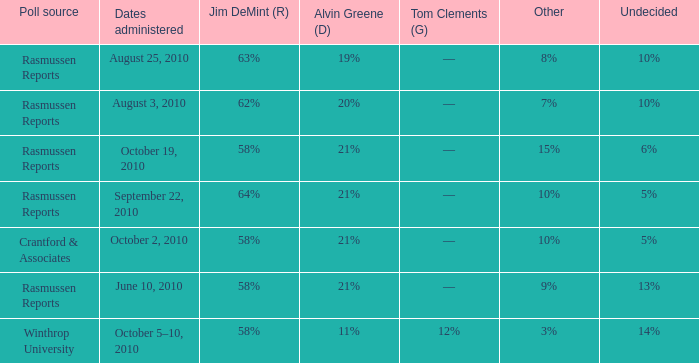I'm looking to parse the entire table for insights. Could you assist me with that? {'header': ['Poll source', 'Dates administered', 'Jim DeMint (R)', 'Alvin Greene (D)', 'Tom Clements (G)', 'Other', 'Undecided'], 'rows': [['Rasmussen Reports', 'August 25, 2010', '63%', '19%', '––', '8%', '10%'], ['Rasmussen Reports', 'August 3, 2010', '62%', '20%', '––', '7%', '10%'], ['Rasmussen Reports', 'October 19, 2010', '58%', '21%', '––', '15%', '6%'], ['Rasmussen Reports', 'September 22, 2010', '64%', '21%', '––', '10%', '5%'], ['Crantford & Associates', 'October 2, 2010', '58%', '21%', '––', '10%', '5%'], ['Rasmussen Reports', 'June 10, 2010', '58%', '21%', '––', '9%', '13%'], ['Winthrop University', 'October 5–10, 2010', '58%', '11%', '12%', '3%', '14%']]} What was the vote for Alvin Green when Jim DeMint was 62%? 20%. 